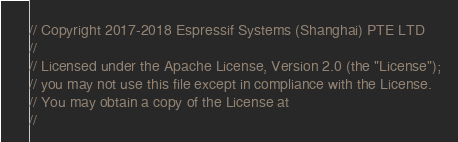<code> <loc_0><loc_0><loc_500><loc_500><_C_>// Copyright 2017-2018 Espressif Systems (Shanghai) PTE LTD
//
// Licensed under the Apache License, Version 2.0 (the "License");
// you may not use this file except in compliance with the License.
// You may obtain a copy of the License at
//</code> 